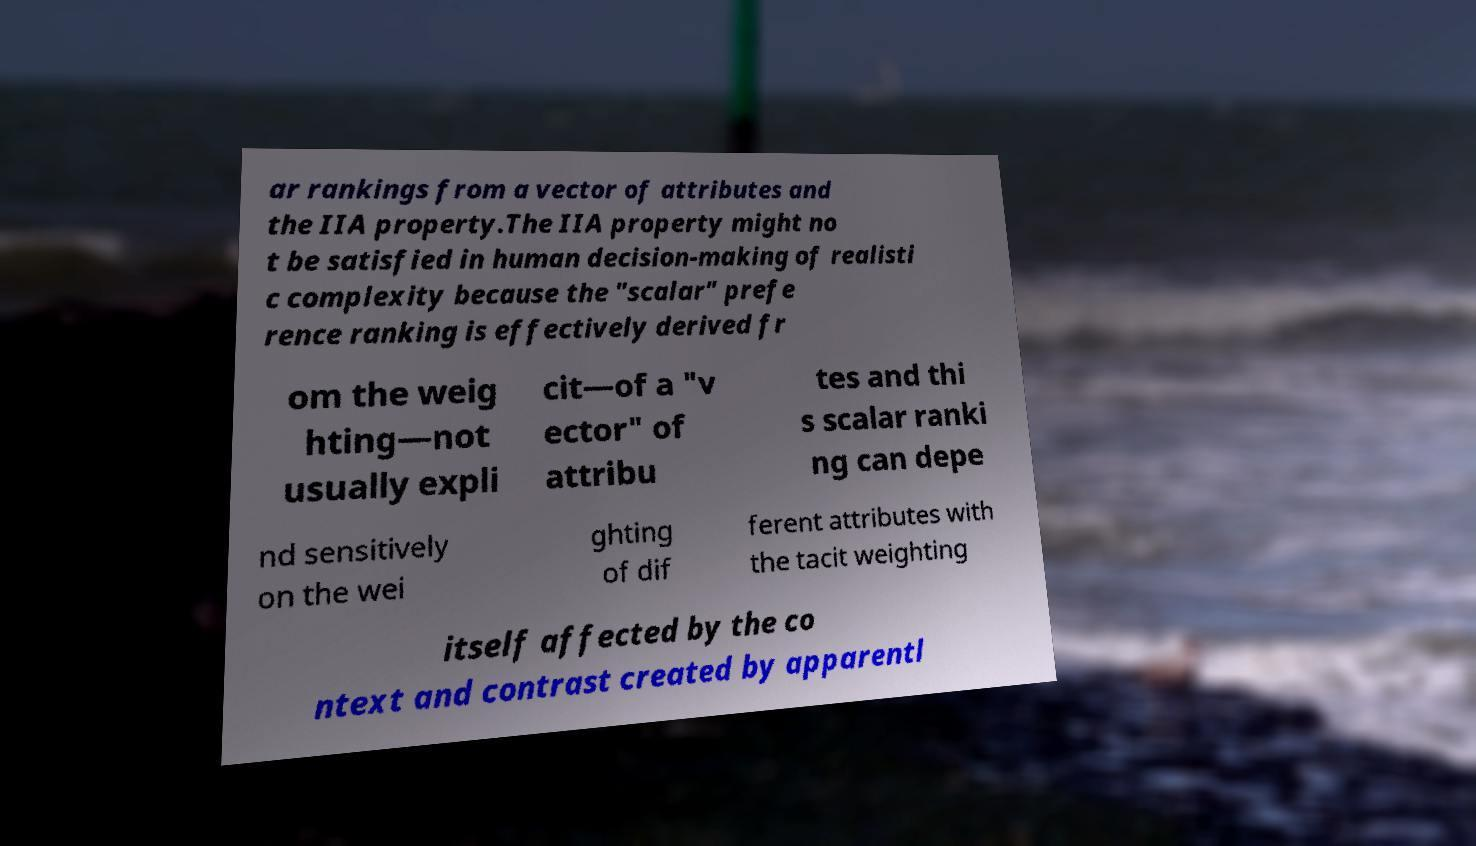Could you assist in decoding the text presented in this image and type it out clearly? ar rankings from a vector of attributes and the IIA property.The IIA property might no t be satisfied in human decision-making of realisti c complexity because the "scalar" prefe rence ranking is effectively derived fr om the weig hting—not usually expli cit—of a "v ector" of attribu tes and thi s scalar ranki ng can depe nd sensitively on the wei ghting of dif ferent attributes with the tacit weighting itself affected by the co ntext and contrast created by apparentl 